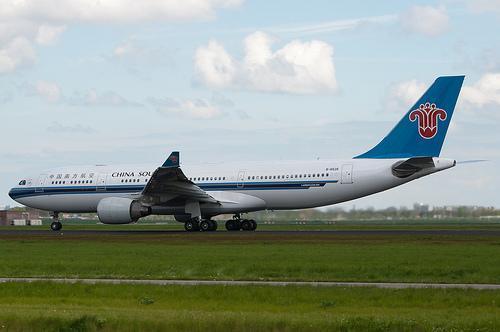How many wings are visible?
Give a very brief answer. 1. How many planes are visible?
Give a very brief answer. 1. 